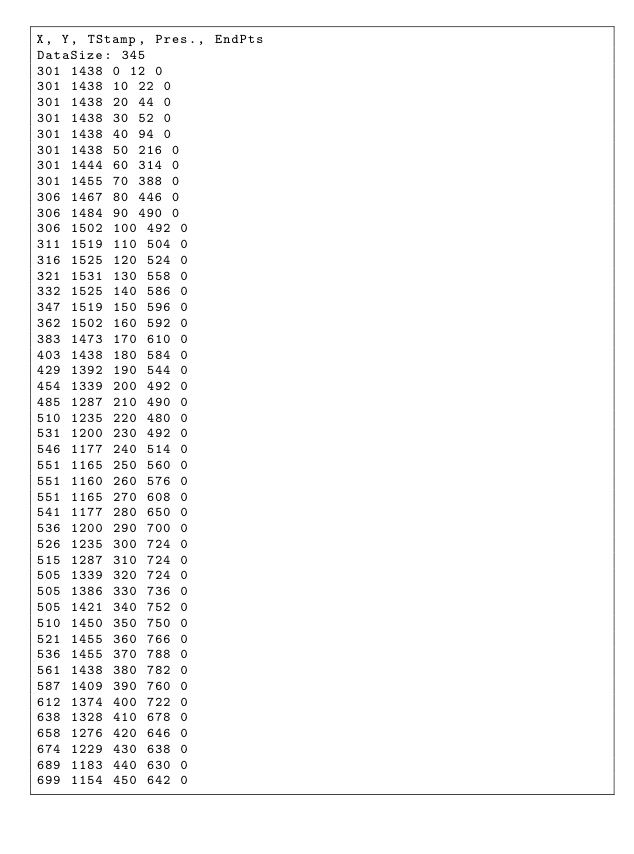<code> <loc_0><loc_0><loc_500><loc_500><_SML_>X, Y, TStamp, Pres., EndPts
DataSize: 345
301 1438 0 12 0
301 1438 10 22 0
301 1438 20 44 0
301 1438 30 52 0
301 1438 40 94 0
301 1438 50 216 0
301 1444 60 314 0
301 1455 70 388 0
306 1467 80 446 0
306 1484 90 490 0
306 1502 100 492 0
311 1519 110 504 0
316 1525 120 524 0
321 1531 130 558 0
332 1525 140 586 0
347 1519 150 596 0
362 1502 160 592 0
383 1473 170 610 0
403 1438 180 584 0
429 1392 190 544 0
454 1339 200 492 0
485 1287 210 490 0
510 1235 220 480 0
531 1200 230 492 0
546 1177 240 514 0
551 1165 250 560 0
551 1160 260 576 0
551 1165 270 608 0
541 1177 280 650 0
536 1200 290 700 0
526 1235 300 724 0
515 1287 310 724 0
505 1339 320 724 0
505 1386 330 736 0
505 1421 340 752 0
510 1450 350 750 0
521 1455 360 766 0
536 1455 370 788 0
561 1438 380 782 0
587 1409 390 760 0
612 1374 400 722 0
638 1328 410 678 0
658 1276 420 646 0
674 1229 430 638 0
689 1183 440 630 0
699 1154 450 642 0</code> 